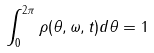Convert formula to latex. <formula><loc_0><loc_0><loc_500><loc_500>\int _ { 0 } ^ { 2 \pi } \rho ( \theta , \omega , t ) d \theta = 1</formula> 